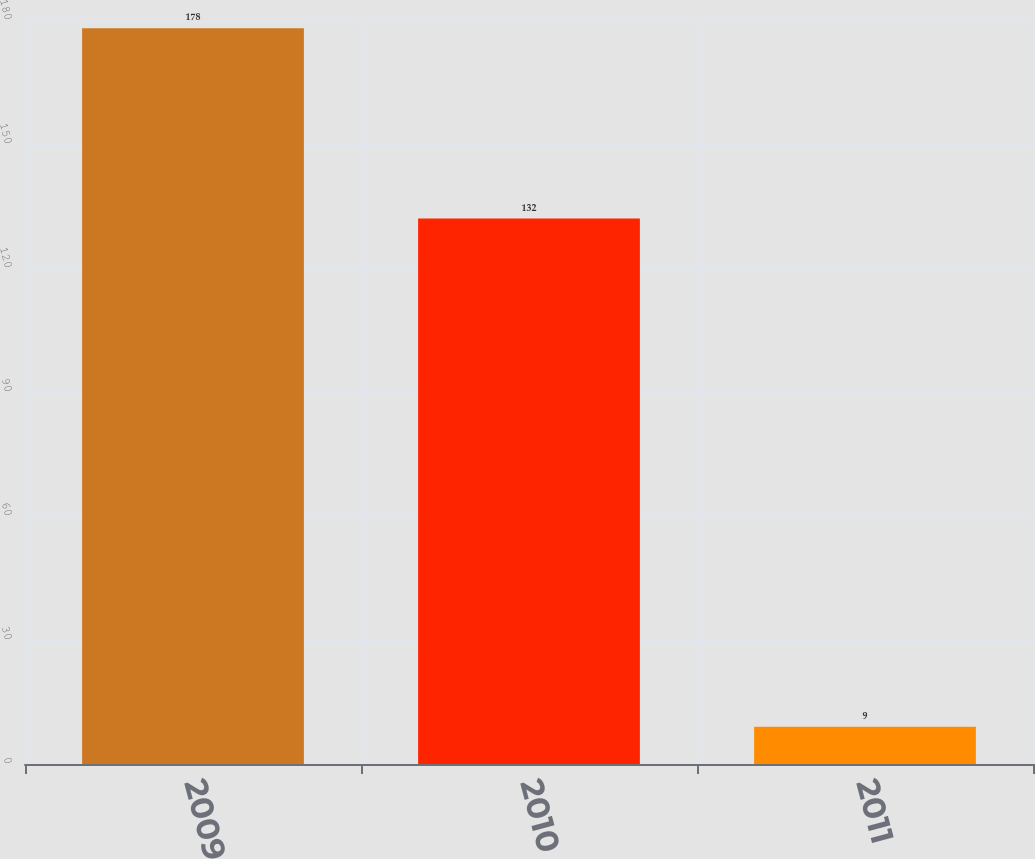Convert chart to OTSL. <chart><loc_0><loc_0><loc_500><loc_500><bar_chart><fcel>2009<fcel>2010<fcel>2011<nl><fcel>178<fcel>132<fcel>9<nl></chart> 